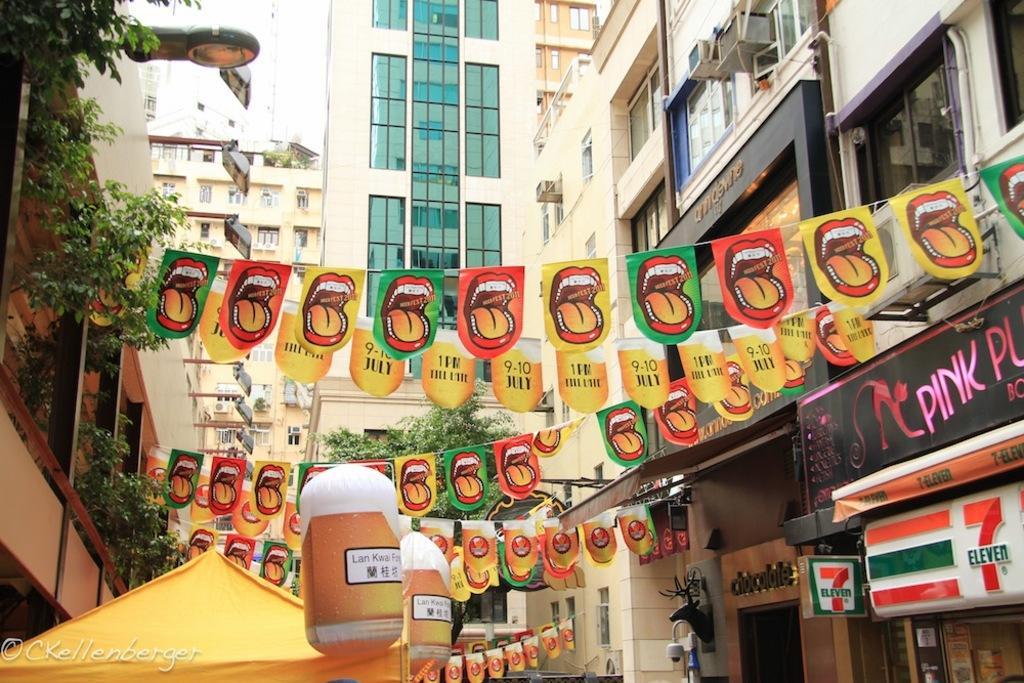Describe this image in one or two sentences. In the picture I can see the buildings and glass windows. I can see the air conditioners on the wall of the building on the top right side. I can see the lights on the wall on the top left side. I can see the designed small flags on the rope hanging on the road. 